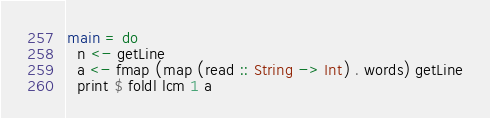<code> <loc_0><loc_0><loc_500><loc_500><_Haskell_>main = do
  n <- getLine
  a <- fmap (map (read :: String -> Int) . words) getLine
  print $ foldl lcm 1 a</code> 